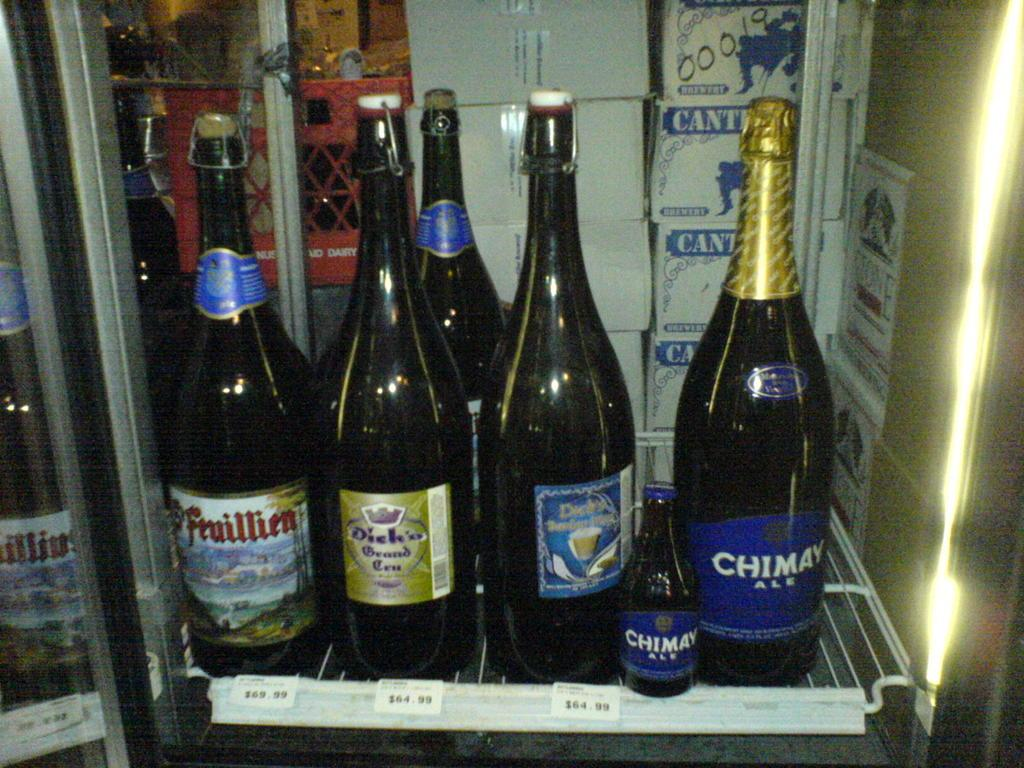<image>
Summarize the visual content of the image. Five bottles of wine with two of them being Chimay are sitting in a fridge. 